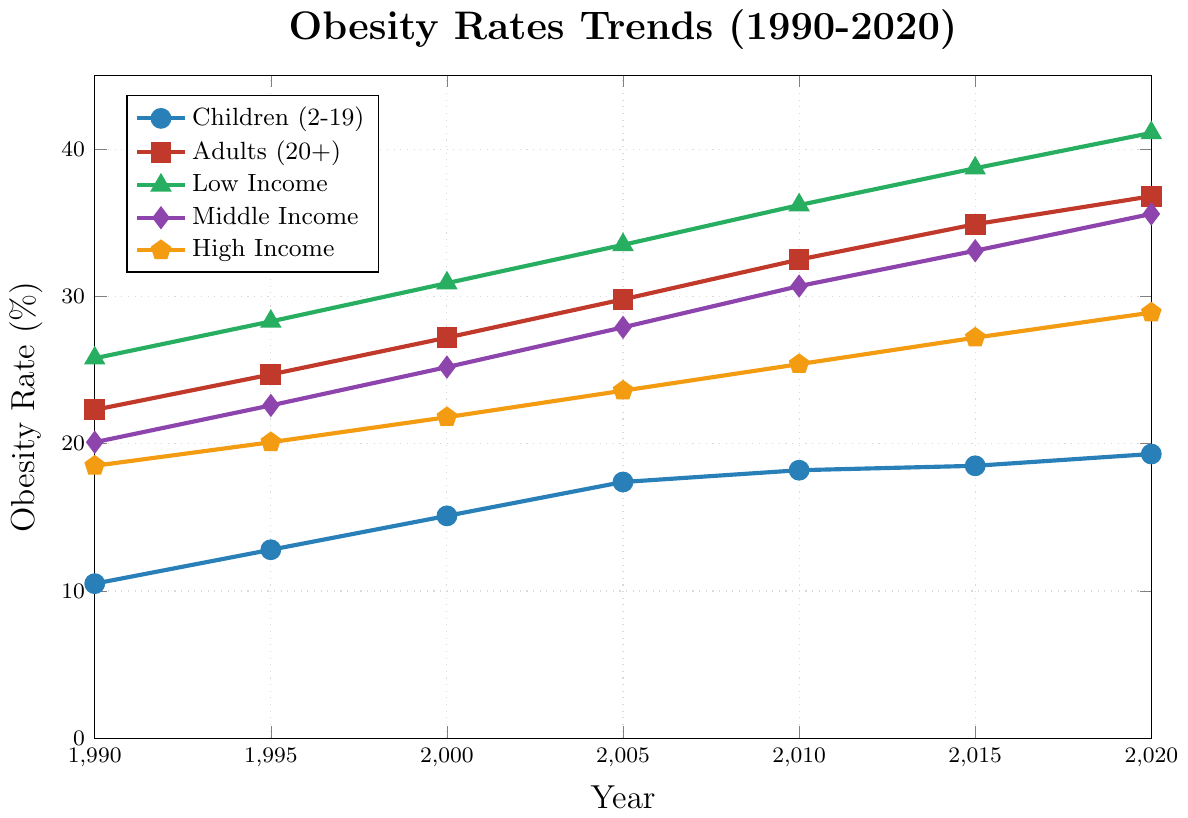Which age group had the highest obesity rate in 2020? Look at the line plot for 2020 and compare the values of "Children (2-19)" and "Adults (20+)". The adult group has a higher value at 36.8% compared to 19.3% for children.
Answer: Adults (20+) How did the obesity rate for high-income individuals change from 1990 to 2020? Identify the data points for high-income individuals in 1990 and 2020. In 1990, the rate is 18.5%, and in 2020, it is 28.9%. Calculate the difference: 28.9 - 18.5 = 10.4.
Answer: Increased by 10.4% What's the average obesity rate for middle-income individuals across the years? Sum the obesity rates for middle-income individuals: 20.1, 22.6, 25.2, 27.9, 30.7, 33.1, and 35.6. The total is 195.2. Divide by the number of data points (7): 195.2 / 7 = 27.17.
Answer: 27.17% Which socioeconomic group had the largest increase in obesity rate from 1990 to 2020? Calculate the difference for each income group. 
Low Income: 41.1 - 25.8 = 15.3
Middle Income: 35.6 - 20.1 = 15.5
High Income: 28.9 - 18.5 = 10.4
The middle-income group had the largest increase of 15.5.
Answer: Middle Income In which year did the obesity rate for adults exceed 30%? Look at the data points for adults (20+) over the years. In the year 2005, the rate exceeded 30% at 32.5%.
Answer: 2005 Compare the obesity rates of children to high-income individuals in 2015. Which group had a higher rate? In 2015, children had an obesity rate of 18.5%, while high-income individuals had a rate of 27.2%. Therefore, the high-income group had a higher rate.
Answer: High Income What is the overall trend in obesity rates for children (2-19) from 1990 to 2020? Observe the line plot for children and notice the progression of values over time. The values increase gradually from 10.5% in 1990 to 19.3% in 2020.
Answer: Increasing trend How much did the obesity rate for low-income individuals increase between 2000 and 2010? Identify the rates for low-income individuals in 2000 and 2010: 30.9% in 2000 and 36.2% in 2010. Calculate the difference: 36.2 - 30.9 = 5.3.
Answer: Increased by 5.3% Which group had the smallest increase in obesity rate from 1990 to 2020? Calculate the difference for each group. 
Children: 19.3 - 10.5 = 8.8
Adults: 36.8 - 22.3 = 14.5
Low Income: 41.1 - 25.8 = 15.3
Middle Income: 35.6 - 20.1 = 15.5
High Income: 28.9 - 18.5 = 10.4
The children group had the smallest increase of 8.8.
Answer: Children What's the difference in obesity rates between low-income and high-income groups in 2020? Identify the rates for low-income and high-income groups in 2020: 41.1% for low-income and 28.9% for high-income. Calculate the difference: 41.1 - 28.9 = 12.2.
Answer: 12.2% 